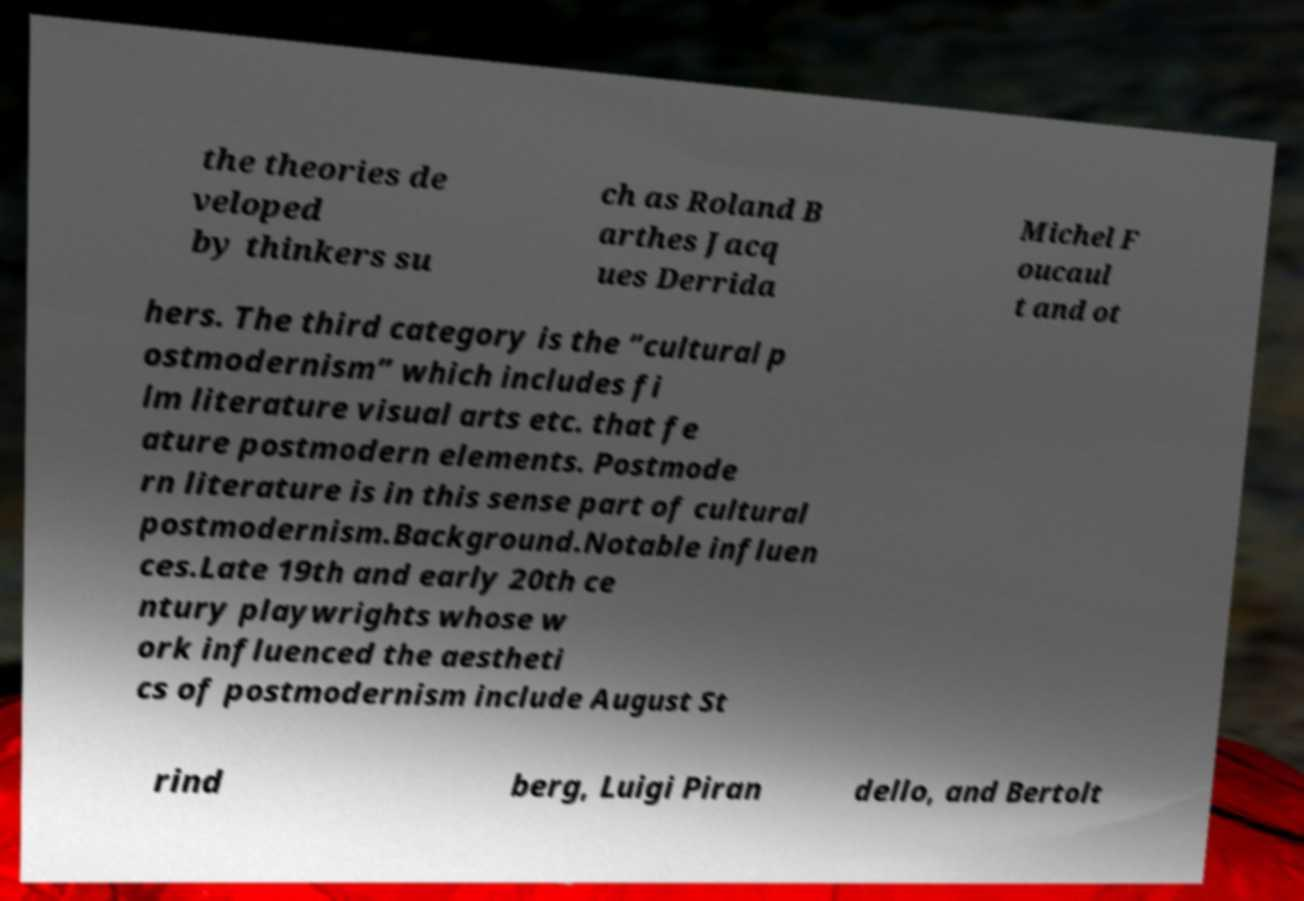Please identify and transcribe the text found in this image. the theories de veloped by thinkers su ch as Roland B arthes Jacq ues Derrida Michel F oucaul t and ot hers. The third category is the “cultural p ostmodernism” which includes fi lm literature visual arts etc. that fe ature postmodern elements. Postmode rn literature is in this sense part of cultural postmodernism.Background.Notable influen ces.Late 19th and early 20th ce ntury playwrights whose w ork influenced the aestheti cs of postmodernism include August St rind berg, Luigi Piran dello, and Bertolt 